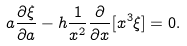Convert formula to latex. <formula><loc_0><loc_0><loc_500><loc_500>a \frac { \partial \xi } { \partial a } - h \frac { 1 } { x ^ { 2 } } \frac { \partial } { \partial x } [ x ^ { 3 } \xi ] = 0 .</formula> 